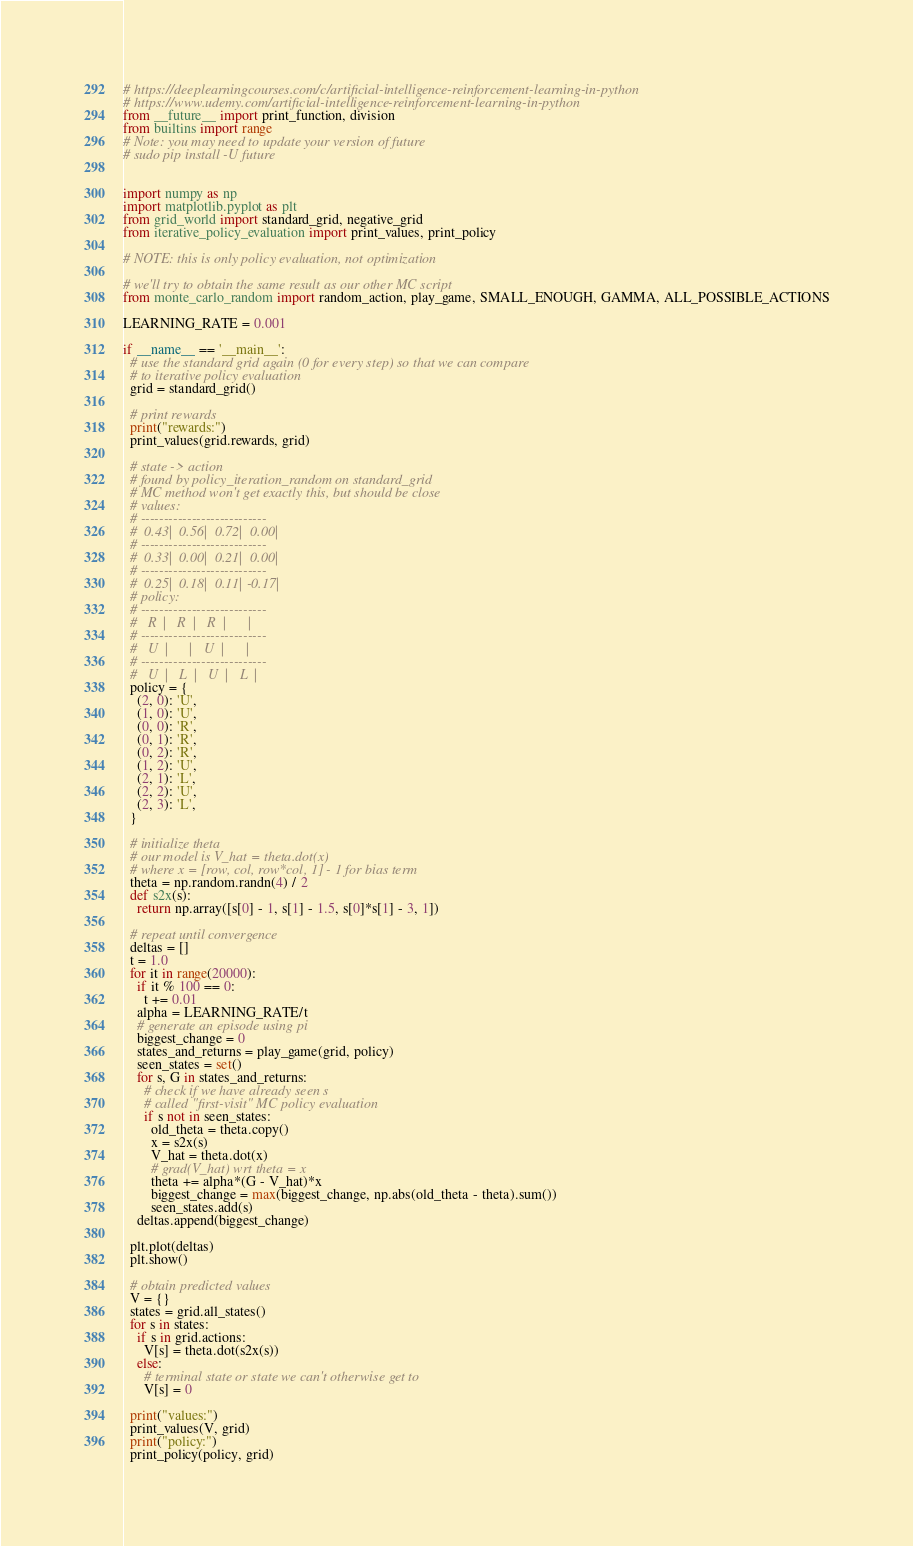<code> <loc_0><loc_0><loc_500><loc_500><_Python_># https://deeplearningcourses.com/c/artificial-intelligence-reinforcement-learning-in-python
# https://www.udemy.com/artificial-intelligence-reinforcement-learning-in-python
from __future__ import print_function, division
from builtins import range
# Note: you may need to update your version of future
# sudo pip install -U future


import numpy as np
import matplotlib.pyplot as plt
from grid_world import standard_grid, negative_grid
from iterative_policy_evaluation import print_values, print_policy

# NOTE: this is only policy evaluation, not optimization

# we'll try to obtain the same result as our other MC script
from monte_carlo_random import random_action, play_game, SMALL_ENOUGH, GAMMA, ALL_POSSIBLE_ACTIONS

LEARNING_RATE = 0.001

if __name__ == '__main__':
  # use the standard grid again (0 for every step) so that we can compare
  # to iterative policy evaluation
  grid = standard_grid()

  # print rewards
  print("rewards:")
  print_values(grid.rewards, grid)

  # state -> action
  # found by policy_iteration_random on standard_grid
  # MC method won't get exactly this, but should be close
  # values:
  # ---------------------------
  #  0.43|  0.56|  0.72|  0.00|
  # ---------------------------
  #  0.33|  0.00|  0.21|  0.00|
  # ---------------------------
  #  0.25|  0.18|  0.11| -0.17|
  # policy:
  # ---------------------------
  #   R  |   R  |   R  |      |
  # ---------------------------
  #   U  |      |   U  |      |
  # ---------------------------
  #   U  |   L  |   U  |   L  |
  policy = {
    (2, 0): 'U',
    (1, 0): 'U',
    (0, 0): 'R',
    (0, 1): 'R',
    (0, 2): 'R',
    (1, 2): 'U',
    (2, 1): 'L',
    (2, 2): 'U',
    (2, 3): 'L',
  }

  # initialize theta
  # our model is V_hat = theta.dot(x)
  # where x = [row, col, row*col, 1] - 1 for bias term
  theta = np.random.randn(4) / 2
  def s2x(s):
    return np.array([s[0] - 1, s[1] - 1.5, s[0]*s[1] - 3, 1])

  # repeat until convergence
  deltas = []
  t = 1.0
  for it in range(20000):
    if it % 100 == 0:
      t += 0.01
    alpha = LEARNING_RATE/t
    # generate an episode using pi
    biggest_change = 0
    states_and_returns = play_game(grid, policy)
    seen_states = set()
    for s, G in states_and_returns:
      # check if we have already seen s
      # called "first-visit" MC policy evaluation
      if s not in seen_states:
        old_theta = theta.copy()
        x = s2x(s)
        V_hat = theta.dot(x)
        # grad(V_hat) wrt theta = x
        theta += alpha*(G - V_hat)*x
        biggest_change = max(biggest_change, np.abs(old_theta - theta).sum())
        seen_states.add(s)
    deltas.append(biggest_change)

  plt.plot(deltas)
  plt.show()

  # obtain predicted values
  V = {}
  states = grid.all_states()
  for s in states:
    if s in grid.actions:
      V[s] = theta.dot(s2x(s))
    else:
      # terminal state or state we can't otherwise get to
      V[s] = 0

  print("values:")
  print_values(V, grid)
  print("policy:")
  print_policy(policy, grid)
</code> 